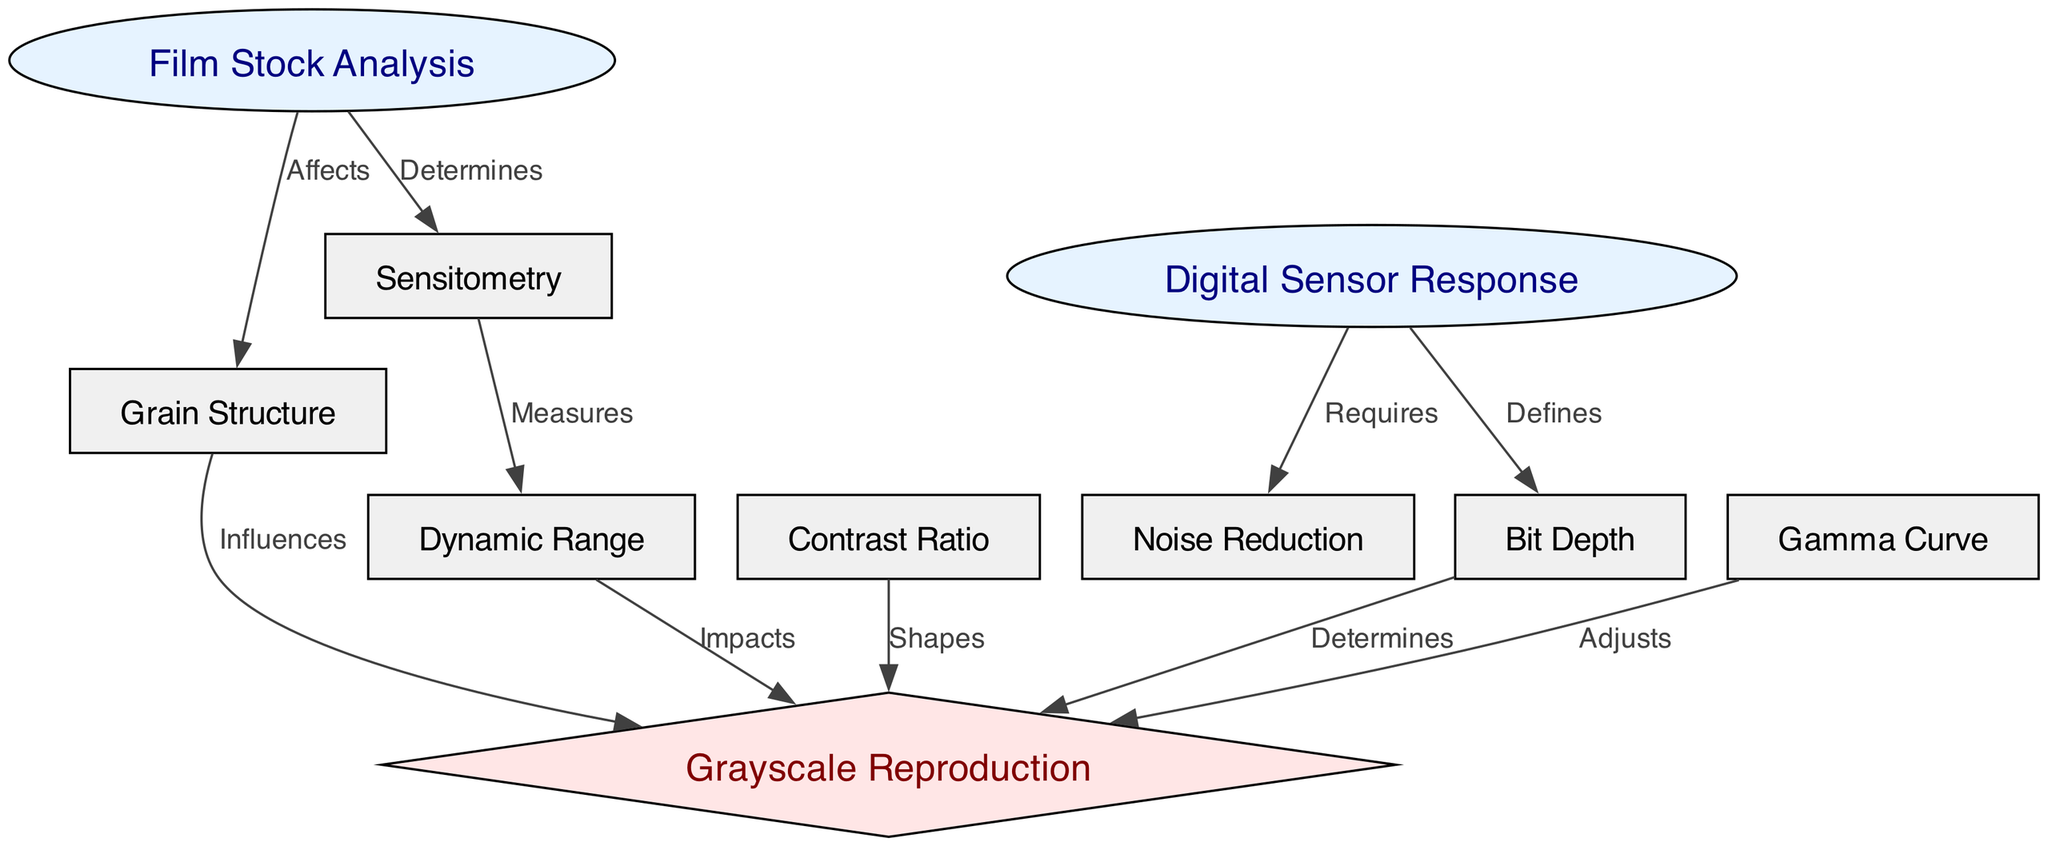What are the two main components analyzed in this diagram? The diagram features two main components: Film Stock Analysis and Digital Sensor Response. These are presented as the top-level nodes in the graph.
Answer: Film Stock Analysis, Digital Sensor Response How many edges are present in the diagram? To determine the number of edges, we can count the connections between the nodes depicted in the diagram. The diagram shows a total of 10 edges connecting the various nodes.
Answer: 10 Which node is influenced by grain structure? The diagram indicates that grain structure has a direct influence on grayscale reproduction as denoted by the directed edge between these two nodes.
Answer: Grayscale Reproduction What does sensitometry measure in this diagram? The diagram shows that sensitometry measures dynamic range, as indicated by the directed edge between the sensitometry node and the dynamic range node.
Answer: Dynamic Range What specific relationship does the digital sensor have with noise reduction? According to the diagram, the digital sensor requires noise reduction, illustrating a necessity for minimizing unwanted noise in digital captures.
Answer: Requires How does bit depth affect grayscale reproduction? The diagram indicates that bit depth determines grayscale reproduction, highlighting its critical role in defining the tonal range achievable in a grayscale image.
Answer: Determines What role does the gamma curve play in grayscale reproduction? The diagram presents that the gamma curve adjusts grayscale reproduction, suggesting that it is a factor in modifying how tones are rendered in black and white imagery.
Answer: Adjusts What connection exists between dynamic range and grayscale reproduction? The diagram shows that dynamic range impacts grayscale reproduction, demonstrating that the range of luminance a system can capture directly influences the quality of the grayscale output.
Answer: Impacts How does contrast ratio shape grayscale reproduction? The diagram states that contrast ratio shapes grayscale reproduction, meaning it affects how different tones and shades are perceived in the final image.
Answer: Shapes 